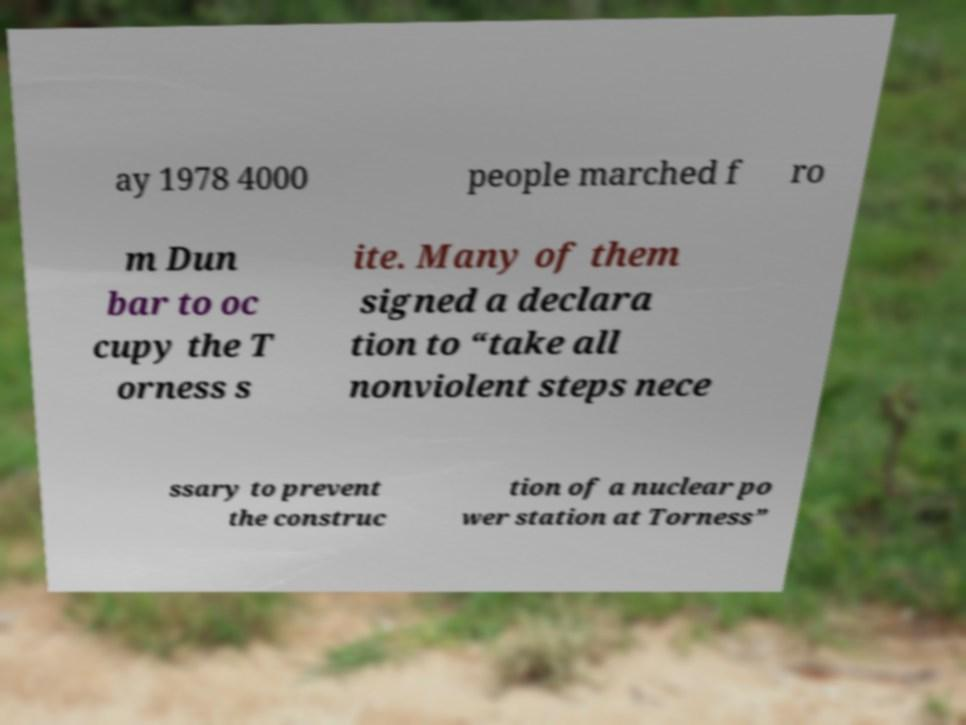Can you read and provide the text displayed in the image?This photo seems to have some interesting text. Can you extract and type it out for me? ay 1978 4000 people marched f ro m Dun bar to oc cupy the T orness s ite. Many of them signed a declara tion to “take all nonviolent steps nece ssary to prevent the construc tion of a nuclear po wer station at Torness” 